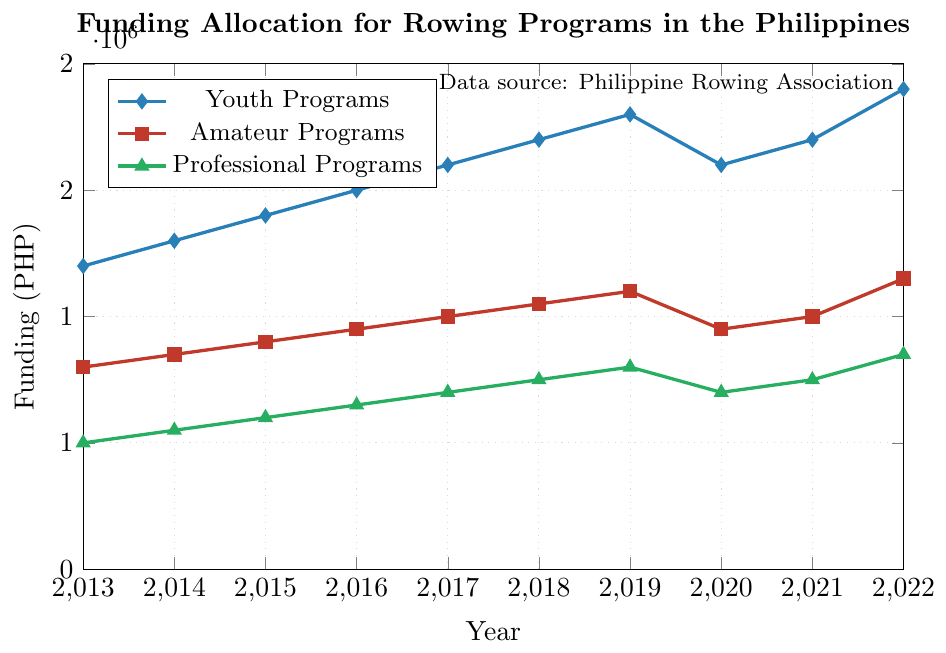What's the total funding for all programs in 2015? Add the funding for Youth Programs, Amateur Programs, and Professional Programs in 2015: 1,400,000 (Youth) + 900,000 (Amateur) + 600,000 (Professional) = 2,900,000
Answer: 2,900,000 Has funding for Youth Programs ever decreased over the decade? Check the Youth Programs line in the plot; it increases every year except from 2019 to 2020, where it decreased from 1,800,000 to 1,600,000
Answer: Yes Which program received the highest funding in 2022? Compare the funding values for Youth Programs, Amateur Programs, and Professional Programs in 2022, and see that Youth Programs received the highest funding of 1,900,000
Answer: Youth Programs What is the average annual funding for Professional Programs over the last decade? Sum the funding for Professional Programs from 2013 to 2022 and divide by 10: (500,000 + 550,000 + 600,000 + 650,000 + 700,000 + 750,000 + 800,000 + 700,000 + 750,000 + 850,000) = 6,850,000, then 6,850,000 / 10 = 685,000
Answer: 685,000 By how much did the funding for Amateur Programs increase from 2013 to 2022? Subtract the funding for Amateur Programs in 2013 from the funding in 2022: 1,150,000 - 800,000 = 350,000
Answer: 350,000 In which year did the funding for all programs experience a decline? Check the years where the funding decreases for all programs simultaneously; in 2020, the funding for Youth Programs, Amateur Programs, and Professional Programs declined compared to 2019
Answer: 2020 Compare the funding trends for Youth and Professional Programs over the decade. What do you notice? The Youth Programs funding generally trends upward, with a temporary decline in 2020 but recovered in 2021 and 2022. Professional Programs funding trends upwards overall, though less steeply, with a similar dip in 2020. Both programs had an increase in 2022.
Answer: Both show an upward trend with a dip in 2020 What is the cumulative funding for Amateur Programs from 2018 to 2022? Sum the funding for Amateur Programs from 2018 to 2022: 1,050,000 + 1,100,000 + 950,000 + 1,000,000 + 1,150,000 = 5,250,000
Answer: 5,250,000 Which year had the smallest gap in funding between Youth Programs and Professional Programs, and what is that gap? Calculate the differences for each year and identify the smallest: 2013: 1,200,000 - 500,000 = 700,000, 2014: 1,300,000 - 550,000 = 750,000, ..., 2022: 1,900,000 - 850,000 = 1,050,000; the smallest gap is in 2013
Answer: 2013, 700,000 